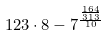Convert formula to latex. <formula><loc_0><loc_0><loc_500><loc_500>1 2 3 \cdot 8 - 7 ^ { \frac { \frac { 1 6 4 } { 3 1 3 } } { 1 0 } }</formula> 